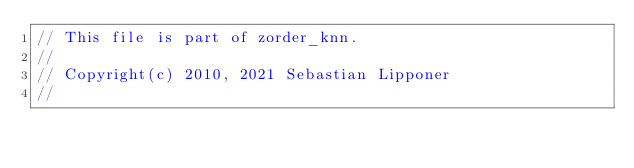<code> <loc_0><loc_0><loc_500><loc_500><_C++_>// This file is part of zorder_knn.
//
// Copyright(c) 2010, 2021 Sebastian Lipponer
//</code> 